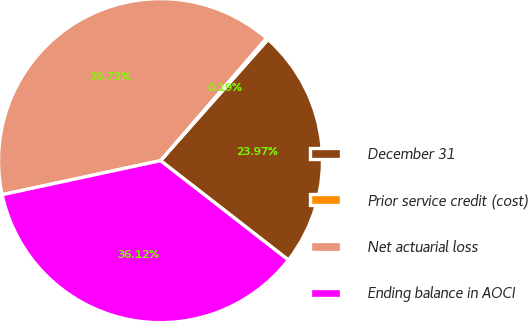Convert chart. <chart><loc_0><loc_0><loc_500><loc_500><pie_chart><fcel>December 31<fcel>Prior service credit (cost)<fcel>Net actuarial loss<fcel>Ending balance in AOCI<nl><fcel>23.97%<fcel>0.19%<fcel>39.73%<fcel>36.12%<nl></chart> 